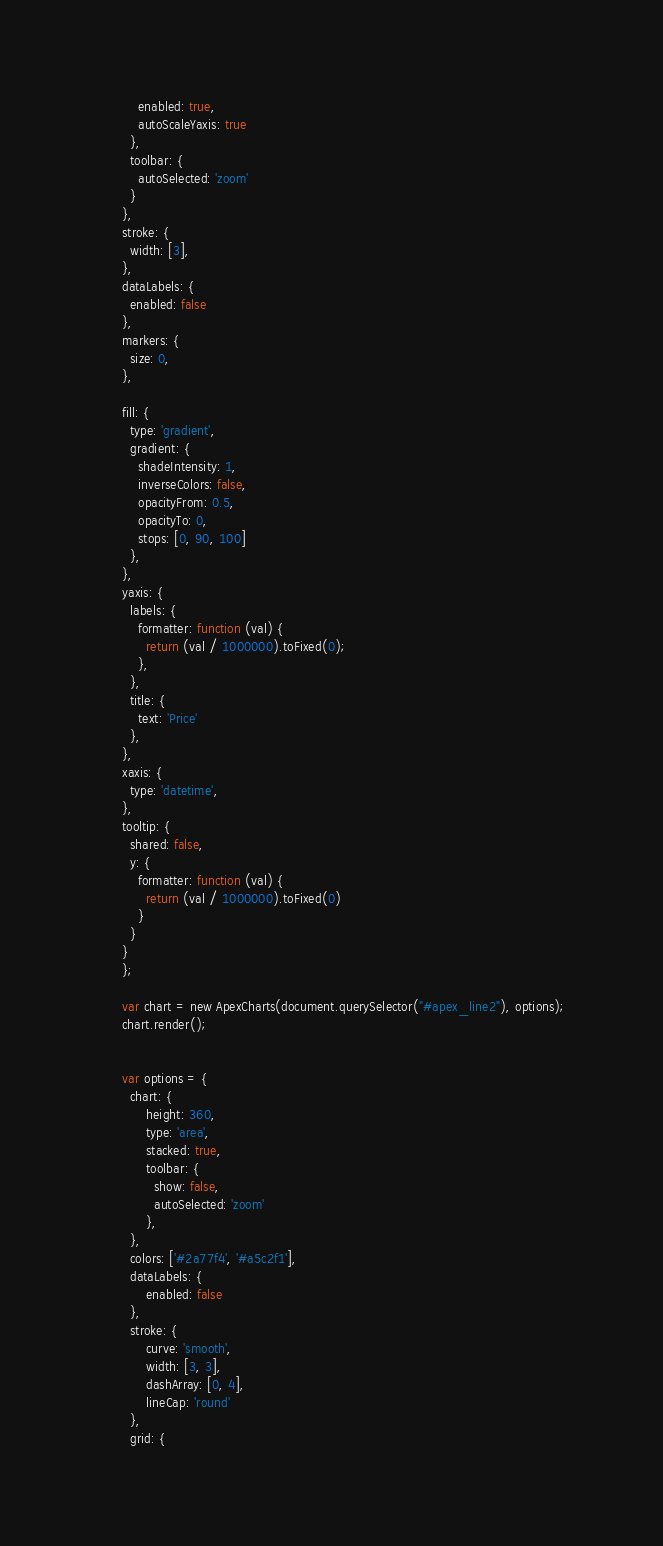Convert code to text. <code><loc_0><loc_0><loc_500><loc_500><_JavaScript_>          enabled: true,
          autoScaleYaxis: true
        },
        toolbar: {
          autoSelected: 'zoom'
        }
      },
      stroke: {
        width: [3],
      },
      dataLabels: {
        enabled: false
      },
      markers: {
        size: 0,
      },
      
      fill: {
        type: 'gradient',
        gradient: {
          shadeIntensity: 1,
          inverseColors: false,
          opacityFrom: 0.5,
          opacityTo: 0,
          stops: [0, 90, 100]
        },
      },
      yaxis: {
        labels: {
          formatter: function (val) {
            return (val / 1000000).toFixed(0);
          },
        },
        title: {
          text: 'Price'
        },
      },
      xaxis: {
        type: 'datetime',
      },
      tooltip: {
        shared: false,
        y: {
          formatter: function (val) {
            return (val / 1000000).toFixed(0)
          }
        }
      }
      };

      var chart = new ApexCharts(document.querySelector("#apex_line2"), options);
      chart.render();


      var options = {
        chart: {
            height: 360,
            type: 'area',
            stacked: true,
            toolbar: {
              show: false,
              autoSelected: 'zoom'
            },
        },
        colors: ['#2a77f4', '#a5c2f1'],
        dataLabels: {
            enabled: false
        },
        stroke: {
            curve: 'smooth',
            width: [3, 3],
            dashArray: [0, 4],
            lineCap: 'round'
        },
        grid: {</code> 